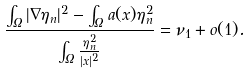<formula> <loc_0><loc_0><loc_500><loc_500>\frac { \int _ { \Omega } | \nabla \eta _ { n } | ^ { 2 } - \int _ { \Omega } a ( x ) \eta _ { n } ^ { 2 } } { \int _ { \Omega } \frac { \eta _ { n } ^ { 2 } } { | x | ^ { 2 } } } = \nu _ { 1 } + o ( 1 ) .</formula> 